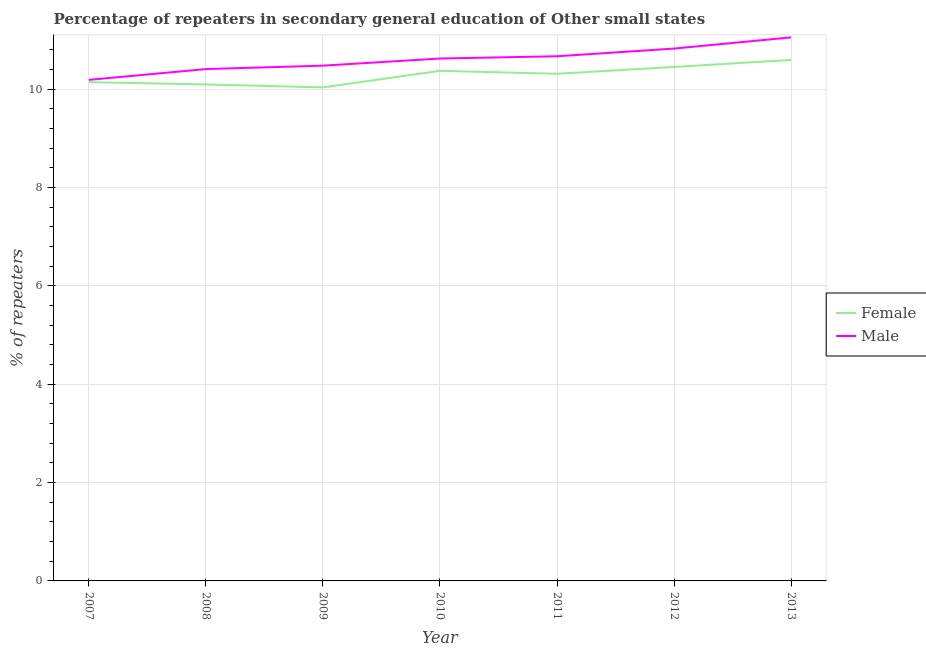How many different coloured lines are there?
Provide a short and direct response. 2. Does the line corresponding to percentage of female repeaters intersect with the line corresponding to percentage of male repeaters?
Your answer should be very brief. No. Is the number of lines equal to the number of legend labels?
Provide a short and direct response. Yes. What is the percentage of male repeaters in 2009?
Make the answer very short. 10.48. Across all years, what is the maximum percentage of female repeaters?
Your answer should be very brief. 10.59. Across all years, what is the minimum percentage of male repeaters?
Ensure brevity in your answer.  10.19. In which year was the percentage of female repeaters maximum?
Offer a very short reply. 2013. What is the total percentage of male repeaters in the graph?
Ensure brevity in your answer.  74.23. What is the difference between the percentage of male repeaters in 2007 and that in 2012?
Ensure brevity in your answer.  -0.64. What is the difference between the percentage of female repeaters in 2008 and the percentage of male repeaters in 2010?
Keep it short and to the point. -0.53. What is the average percentage of male repeaters per year?
Ensure brevity in your answer.  10.6. In the year 2013, what is the difference between the percentage of female repeaters and percentage of male repeaters?
Provide a short and direct response. -0.46. In how many years, is the percentage of male repeaters greater than 10 %?
Your answer should be very brief. 7. What is the ratio of the percentage of female repeaters in 2007 to that in 2011?
Your response must be concise. 0.98. Is the percentage of female repeaters in 2009 less than that in 2010?
Make the answer very short. Yes. Is the difference between the percentage of male repeaters in 2010 and 2012 greater than the difference between the percentage of female repeaters in 2010 and 2012?
Make the answer very short. No. What is the difference between the highest and the second highest percentage of female repeaters?
Provide a succinct answer. 0.14. What is the difference between the highest and the lowest percentage of male repeaters?
Make the answer very short. 0.86. How many lines are there?
Provide a succinct answer. 2. What is the difference between two consecutive major ticks on the Y-axis?
Ensure brevity in your answer.  2. Does the graph contain any zero values?
Provide a short and direct response. No. Where does the legend appear in the graph?
Your answer should be very brief. Center right. How are the legend labels stacked?
Provide a short and direct response. Vertical. What is the title of the graph?
Make the answer very short. Percentage of repeaters in secondary general education of Other small states. What is the label or title of the X-axis?
Make the answer very short. Year. What is the label or title of the Y-axis?
Offer a terse response. % of repeaters. What is the % of repeaters of Female in 2007?
Provide a succinct answer. 10.14. What is the % of repeaters in Male in 2007?
Offer a very short reply. 10.19. What is the % of repeaters in Female in 2008?
Provide a short and direct response. 10.09. What is the % of repeaters of Male in 2008?
Your response must be concise. 10.41. What is the % of repeaters of Female in 2009?
Offer a very short reply. 10.03. What is the % of repeaters in Male in 2009?
Your answer should be compact. 10.48. What is the % of repeaters of Female in 2010?
Give a very brief answer. 10.37. What is the % of repeaters in Male in 2010?
Provide a short and direct response. 10.62. What is the % of repeaters in Female in 2011?
Ensure brevity in your answer.  10.31. What is the % of repeaters of Male in 2011?
Your answer should be very brief. 10.67. What is the % of repeaters of Female in 2012?
Give a very brief answer. 10.45. What is the % of repeaters of Male in 2012?
Ensure brevity in your answer.  10.82. What is the % of repeaters of Female in 2013?
Offer a very short reply. 10.59. What is the % of repeaters in Male in 2013?
Give a very brief answer. 11.05. Across all years, what is the maximum % of repeaters in Female?
Your answer should be very brief. 10.59. Across all years, what is the maximum % of repeaters of Male?
Make the answer very short. 11.05. Across all years, what is the minimum % of repeaters of Female?
Make the answer very short. 10.03. Across all years, what is the minimum % of repeaters of Male?
Keep it short and to the point. 10.19. What is the total % of repeaters of Female in the graph?
Your response must be concise. 71.99. What is the total % of repeaters in Male in the graph?
Your answer should be very brief. 74.23. What is the difference between the % of repeaters in Female in 2007 and that in 2008?
Offer a very short reply. 0.05. What is the difference between the % of repeaters in Male in 2007 and that in 2008?
Provide a succinct answer. -0.22. What is the difference between the % of repeaters in Female in 2007 and that in 2009?
Make the answer very short. 0.11. What is the difference between the % of repeaters in Male in 2007 and that in 2009?
Your response must be concise. -0.29. What is the difference between the % of repeaters in Female in 2007 and that in 2010?
Offer a terse response. -0.23. What is the difference between the % of repeaters of Male in 2007 and that in 2010?
Your answer should be compact. -0.43. What is the difference between the % of repeaters of Female in 2007 and that in 2011?
Offer a terse response. -0.17. What is the difference between the % of repeaters in Male in 2007 and that in 2011?
Provide a short and direct response. -0.48. What is the difference between the % of repeaters in Female in 2007 and that in 2012?
Offer a very short reply. -0.31. What is the difference between the % of repeaters of Male in 2007 and that in 2012?
Make the answer very short. -0.64. What is the difference between the % of repeaters in Female in 2007 and that in 2013?
Make the answer very short. -0.45. What is the difference between the % of repeaters in Male in 2007 and that in 2013?
Give a very brief answer. -0.86. What is the difference between the % of repeaters of Female in 2008 and that in 2009?
Your response must be concise. 0.06. What is the difference between the % of repeaters in Male in 2008 and that in 2009?
Give a very brief answer. -0.07. What is the difference between the % of repeaters in Female in 2008 and that in 2010?
Offer a terse response. -0.28. What is the difference between the % of repeaters of Male in 2008 and that in 2010?
Offer a very short reply. -0.21. What is the difference between the % of repeaters of Female in 2008 and that in 2011?
Provide a succinct answer. -0.22. What is the difference between the % of repeaters in Male in 2008 and that in 2011?
Your response must be concise. -0.26. What is the difference between the % of repeaters of Female in 2008 and that in 2012?
Make the answer very short. -0.36. What is the difference between the % of repeaters of Male in 2008 and that in 2012?
Your response must be concise. -0.42. What is the difference between the % of repeaters of Female in 2008 and that in 2013?
Your response must be concise. -0.5. What is the difference between the % of repeaters in Male in 2008 and that in 2013?
Your answer should be compact. -0.64. What is the difference between the % of repeaters of Female in 2009 and that in 2010?
Ensure brevity in your answer.  -0.34. What is the difference between the % of repeaters of Male in 2009 and that in 2010?
Provide a succinct answer. -0.14. What is the difference between the % of repeaters in Female in 2009 and that in 2011?
Give a very brief answer. -0.28. What is the difference between the % of repeaters in Male in 2009 and that in 2011?
Give a very brief answer. -0.19. What is the difference between the % of repeaters of Female in 2009 and that in 2012?
Your answer should be compact. -0.42. What is the difference between the % of repeaters in Male in 2009 and that in 2012?
Offer a very short reply. -0.35. What is the difference between the % of repeaters in Female in 2009 and that in 2013?
Offer a very short reply. -0.56. What is the difference between the % of repeaters of Male in 2009 and that in 2013?
Give a very brief answer. -0.57. What is the difference between the % of repeaters of Female in 2010 and that in 2011?
Provide a short and direct response. 0.06. What is the difference between the % of repeaters in Male in 2010 and that in 2011?
Your answer should be very brief. -0.05. What is the difference between the % of repeaters in Female in 2010 and that in 2012?
Your response must be concise. -0.08. What is the difference between the % of repeaters of Male in 2010 and that in 2012?
Your answer should be compact. -0.2. What is the difference between the % of repeaters of Female in 2010 and that in 2013?
Give a very brief answer. -0.22. What is the difference between the % of repeaters in Male in 2010 and that in 2013?
Give a very brief answer. -0.43. What is the difference between the % of repeaters in Female in 2011 and that in 2012?
Your answer should be very brief. -0.14. What is the difference between the % of repeaters in Male in 2011 and that in 2012?
Give a very brief answer. -0.16. What is the difference between the % of repeaters in Female in 2011 and that in 2013?
Ensure brevity in your answer.  -0.28. What is the difference between the % of repeaters in Male in 2011 and that in 2013?
Provide a short and direct response. -0.38. What is the difference between the % of repeaters in Female in 2012 and that in 2013?
Offer a very short reply. -0.14. What is the difference between the % of repeaters in Male in 2012 and that in 2013?
Make the answer very short. -0.23. What is the difference between the % of repeaters of Female in 2007 and the % of repeaters of Male in 2008?
Your response must be concise. -0.27. What is the difference between the % of repeaters of Female in 2007 and the % of repeaters of Male in 2009?
Provide a short and direct response. -0.34. What is the difference between the % of repeaters in Female in 2007 and the % of repeaters in Male in 2010?
Ensure brevity in your answer.  -0.48. What is the difference between the % of repeaters of Female in 2007 and the % of repeaters of Male in 2011?
Keep it short and to the point. -0.53. What is the difference between the % of repeaters in Female in 2007 and the % of repeaters in Male in 2012?
Provide a succinct answer. -0.68. What is the difference between the % of repeaters in Female in 2007 and the % of repeaters in Male in 2013?
Make the answer very short. -0.91. What is the difference between the % of repeaters in Female in 2008 and the % of repeaters in Male in 2009?
Provide a short and direct response. -0.38. What is the difference between the % of repeaters of Female in 2008 and the % of repeaters of Male in 2010?
Give a very brief answer. -0.53. What is the difference between the % of repeaters in Female in 2008 and the % of repeaters in Male in 2011?
Offer a very short reply. -0.57. What is the difference between the % of repeaters in Female in 2008 and the % of repeaters in Male in 2012?
Your answer should be very brief. -0.73. What is the difference between the % of repeaters of Female in 2008 and the % of repeaters of Male in 2013?
Ensure brevity in your answer.  -0.96. What is the difference between the % of repeaters of Female in 2009 and the % of repeaters of Male in 2010?
Keep it short and to the point. -0.59. What is the difference between the % of repeaters of Female in 2009 and the % of repeaters of Male in 2011?
Provide a succinct answer. -0.63. What is the difference between the % of repeaters of Female in 2009 and the % of repeaters of Male in 2012?
Provide a succinct answer. -0.79. What is the difference between the % of repeaters of Female in 2009 and the % of repeaters of Male in 2013?
Give a very brief answer. -1.02. What is the difference between the % of repeaters in Female in 2010 and the % of repeaters in Male in 2011?
Your response must be concise. -0.3. What is the difference between the % of repeaters in Female in 2010 and the % of repeaters in Male in 2012?
Ensure brevity in your answer.  -0.45. What is the difference between the % of repeaters of Female in 2010 and the % of repeaters of Male in 2013?
Provide a succinct answer. -0.68. What is the difference between the % of repeaters of Female in 2011 and the % of repeaters of Male in 2012?
Provide a short and direct response. -0.51. What is the difference between the % of repeaters in Female in 2011 and the % of repeaters in Male in 2013?
Provide a succinct answer. -0.74. What is the difference between the % of repeaters in Female in 2012 and the % of repeaters in Male in 2013?
Provide a succinct answer. -0.6. What is the average % of repeaters of Female per year?
Offer a very short reply. 10.29. What is the average % of repeaters of Male per year?
Your answer should be compact. 10.6. In the year 2007, what is the difference between the % of repeaters in Female and % of repeaters in Male?
Ensure brevity in your answer.  -0.05. In the year 2008, what is the difference between the % of repeaters of Female and % of repeaters of Male?
Offer a very short reply. -0.31. In the year 2009, what is the difference between the % of repeaters of Female and % of repeaters of Male?
Ensure brevity in your answer.  -0.44. In the year 2011, what is the difference between the % of repeaters of Female and % of repeaters of Male?
Offer a very short reply. -0.36. In the year 2012, what is the difference between the % of repeaters of Female and % of repeaters of Male?
Provide a succinct answer. -0.37. In the year 2013, what is the difference between the % of repeaters in Female and % of repeaters in Male?
Your response must be concise. -0.46. What is the ratio of the % of repeaters in Male in 2007 to that in 2008?
Keep it short and to the point. 0.98. What is the ratio of the % of repeaters in Female in 2007 to that in 2009?
Provide a succinct answer. 1.01. What is the ratio of the % of repeaters in Male in 2007 to that in 2009?
Ensure brevity in your answer.  0.97. What is the ratio of the % of repeaters in Female in 2007 to that in 2010?
Provide a short and direct response. 0.98. What is the ratio of the % of repeaters in Male in 2007 to that in 2010?
Keep it short and to the point. 0.96. What is the ratio of the % of repeaters of Female in 2007 to that in 2011?
Make the answer very short. 0.98. What is the ratio of the % of repeaters in Male in 2007 to that in 2011?
Offer a terse response. 0.95. What is the ratio of the % of repeaters of Female in 2007 to that in 2012?
Provide a succinct answer. 0.97. What is the ratio of the % of repeaters in Male in 2007 to that in 2012?
Make the answer very short. 0.94. What is the ratio of the % of repeaters of Female in 2007 to that in 2013?
Your answer should be compact. 0.96. What is the ratio of the % of repeaters in Male in 2007 to that in 2013?
Keep it short and to the point. 0.92. What is the ratio of the % of repeaters in Female in 2008 to that in 2009?
Offer a very short reply. 1.01. What is the ratio of the % of repeaters of Male in 2008 to that in 2009?
Provide a succinct answer. 0.99. What is the ratio of the % of repeaters of Female in 2008 to that in 2010?
Make the answer very short. 0.97. What is the ratio of the % of repeaters of Male in 2008 to that in 2010?
Provide a short and direct response. 0.98. What is the ratio of the % of repeaters in Male in 2008 to that in 2011?
Keep it short and to the point. 0.98. What is the ratio of the % of repeaters in Female in 2008 to that in 2012?
Your answer should be very brief. 0.97. What is the ratio of the % of repeaters in Male in 2008 to that in 2012?
Your answer should be compact. 0.96. What is the ratio of the % of repeaters in Female in 2008 to that in 2013?
Your answer should be compact. 0.95. What is the ratio of the % of repeaters in Male in 2008 to that in 2013?
Make the answer very short. 0.94. What is the ratio of the % of repeaters of Female in 2009 to that in 2010?
Give a very brief answer. 0.97. What is the ratio of the % of repeaters in Male in 2009 to that in 2010?
Your answer should be very brief. 0.99. What is the ratio of the % of repeaters in Female in 2009 to that in 2011?
Offer a terse response. 0.97. What is the ratio of the % of repeaters in Male in 2009 to that in 2011?
Keep it short and to the point. 0.98. What is the ratio of the % of repeaters in Female in 2009 to that in 2012?
Provide a short and direct response. 0.96. What is the ratio of the % of repeaters of Male in 2009 to that in 2012?
Make the answer very short. 0.97. What is the ratio of the % of repeaters in Female in 2009 to that in 2013?
Provide a succinct answer. 0.95. What is the ratio of the % of repeaters of Male in 2009 to that in 2013?
Offer a very short reply. 0.95. What is the ratio of the % of repeaters of Female in 2010 to that in 2011?
Offer a terse response. 1.01. What is the ratio of the % of repeaters of Female in 2010 to that in 2012?
Your answer should be compact. 0.99. What is the ratio of the % of repeaters of Male in 2010 to that in 2012?
Offer a terse response. 0.98. What is the ratio of the % of repeaters of Female in 2010 to that in 2013?
Offer a terse response. 0.98. What is the ratio of the % of repeaters of Male in 2010 to that in 2013?
Make the answer very short. 0.96. What is the ratio of the % of repeaters of Female in 2011 to that in 2012?
Your answer should be compact. 0.99. What is the ratio of the % of repeaters of Male in 2011 to that in 2012?
Your answer should be compact. 0.99. What is the ratio of the % of repeaters in Female in 2011 to that in 2013?
Provide a succinct answer. 0.97. What is the ratio of the % of repeaters in Male in 2011 to that in 2013?
Provide a short and direct response. 0.97. What is the ratio of the % of repeaters in Female in 2012 to that in 2013?
Give a very brief answer. 0.99. What is the ratio of the % of repeaters in Male in 2012 to that in 2013?
Keep it short and to the point. 0.98. What is the difference between the highest and the second highest % of repeaters of Female?
Provide a short and direct response. 0.14. What is the difference between the highest and the second highest % of repeaters in Male?
Offer a terse response. 0.23. What is the difference between the highest and the lowest % of repeaters in Female?
Offer a very short reply. 0.56. What is the difference between the highest and the lowest % of repeaters of Male?
Give a very brief answer. 0.86. 